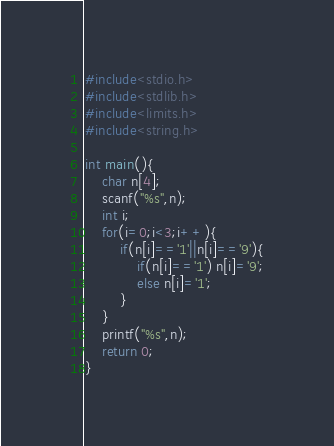<code> <loc_0><loc_0><loc_500><loc_500><_C_>#include<stdio.h>
#include<stdlib.h>
#include<limits.h>
#include<string.h>

int main(){
    char n[4];
    scanf("%s",n);
    int i;
    for(i=0;i<3;i++){
        if(n[i]=='1'||n[i]=='9'){
            if(n[i]=='1') n[i]='9';
            else n[i]='1';
        }
    }
    printf("%s",n);
    return 0;
}</code> 